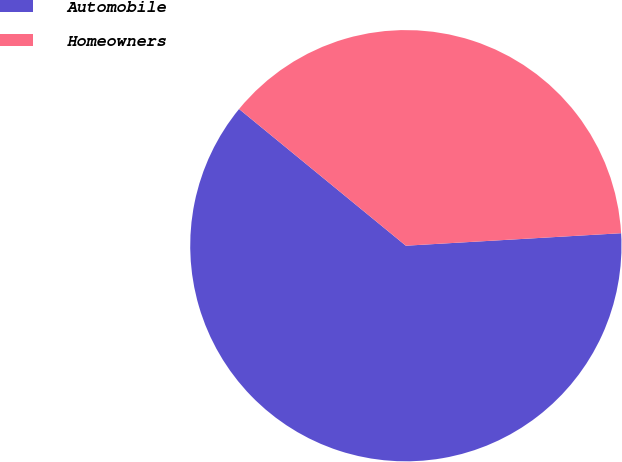<chart> <loc_0><loc_0><loc_500><loc_500><pie_chart><fcel>Automobile<fcel>Homeowners<nl><fcel>61.85%<fcel>38.15%<nl></chart> 